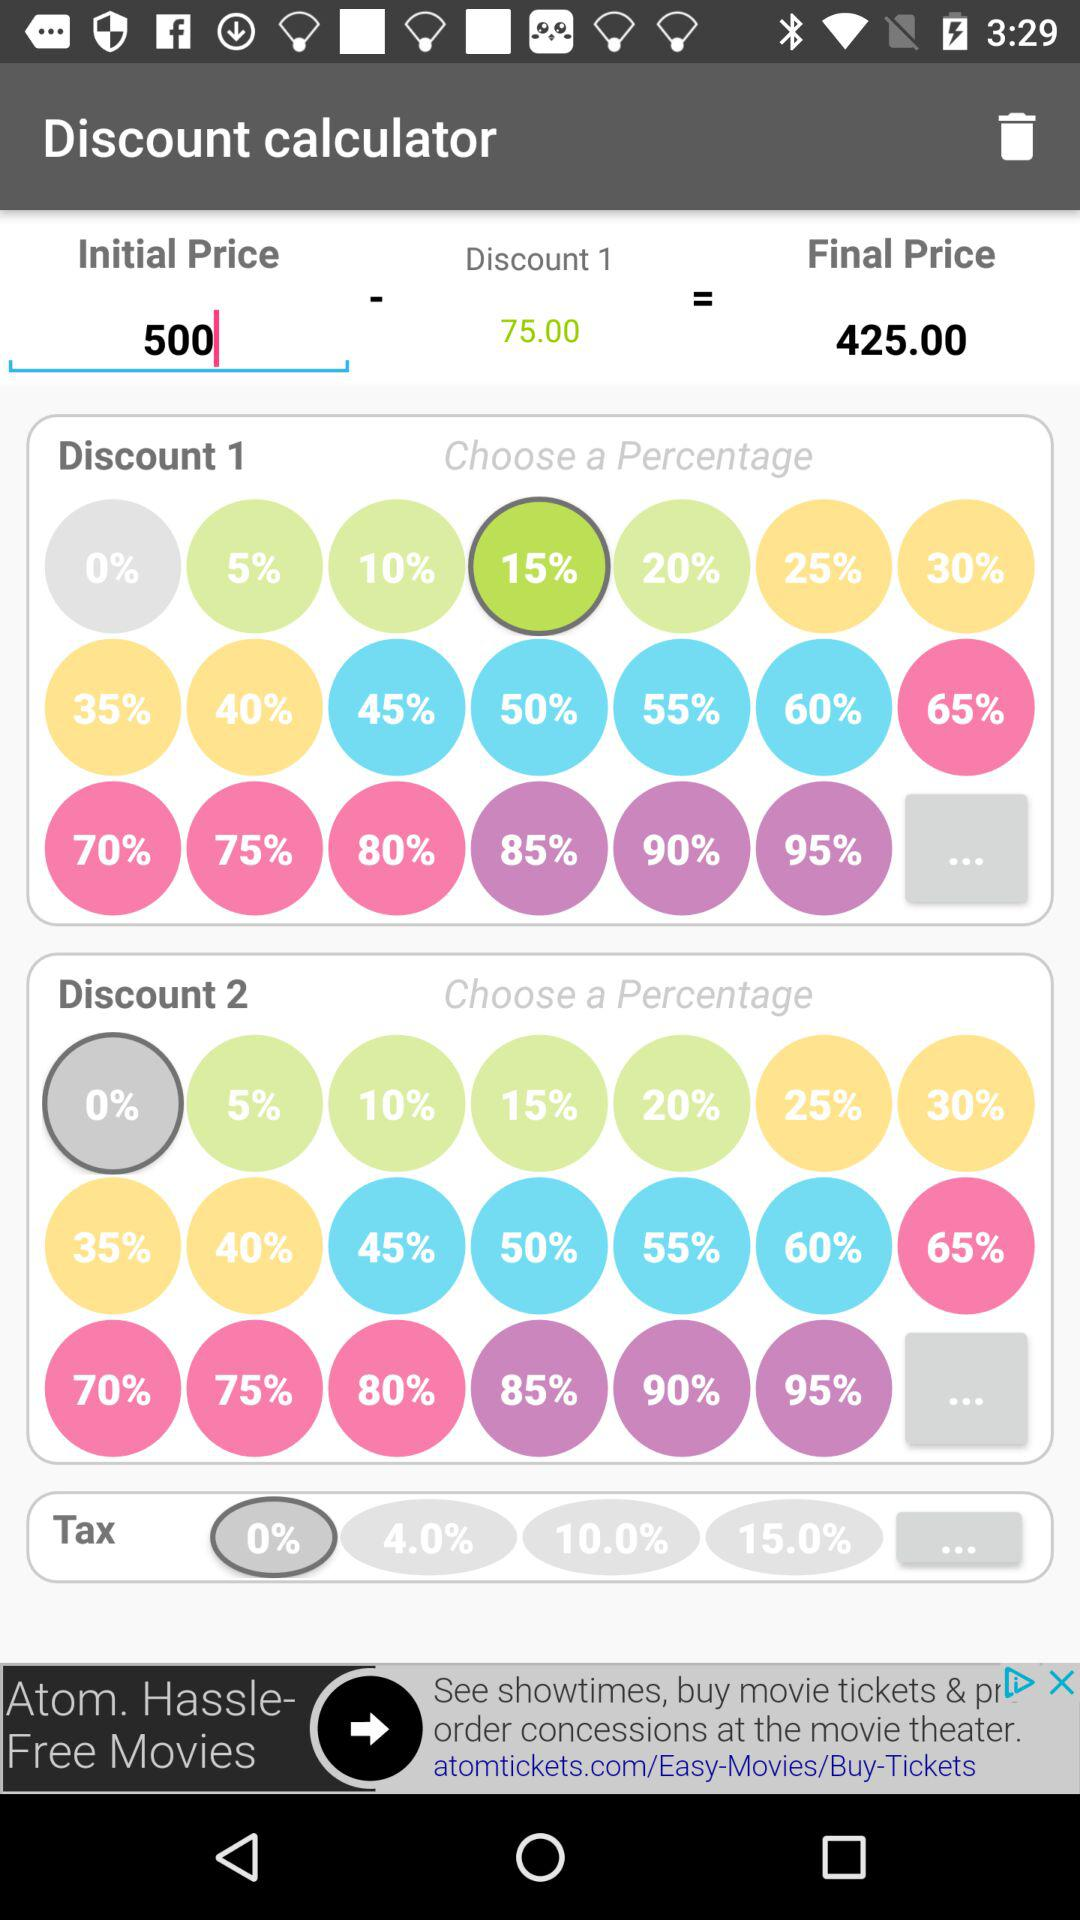What is the discounted price of "Discount 1"? The discounted price is 425.00. 